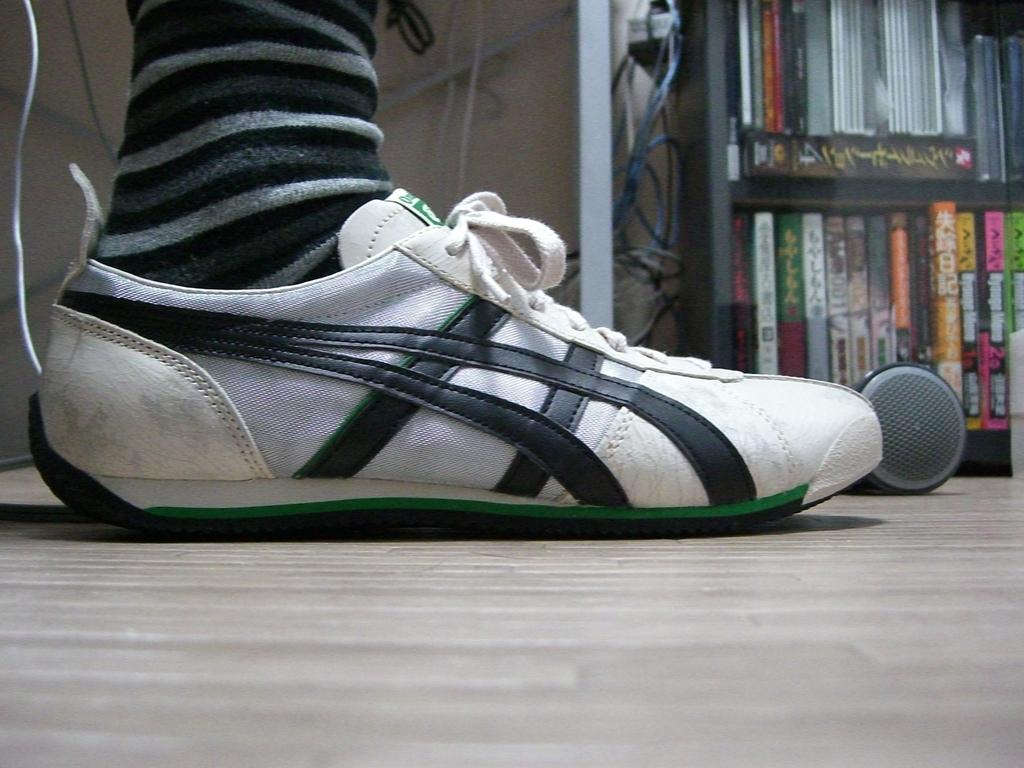What can be seen on the floor in the image? There is a person's shoes visible on the floor. Where are the books located in the image? The books are kept in a rack in the top right of the image. Where is the basket with a crown and sponge located in the image? There is no basket, crown, or sponge present in the image. 